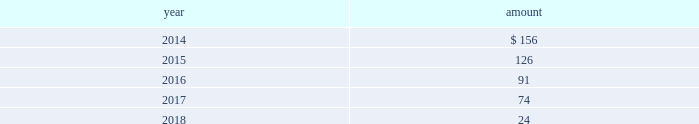The impairment tests performed for intangible assets as of july 31 , 2013 , 2012 and 2011 indicated no impairment charges were required .
Estimated amortization expense for finite-lived intangible assets for each of the five succeeding years is as follows : ( in millions ) .
Indefinite-lived acquired management contracts in july 2013 , in connection with the credit suisse etf transaction , the company acquired $ 231 million of indefinite-lived management contracts .
In march 2012 , in connection with the claymore transaction , the company acquired $ 163 million of indefinite-lived etp management contracts .
Finite-lived acquired management contracts in october 2013 , in connection with the mgpa transaction , the company acquired $ 29 million of finite-lived management contracts with a weighted-average estimated useful life of approximately eight years .
In september 2012 , in connection with the srpep transaction , the company acquired $ 40 million of finite- lived management contracts with a weighted-average estimated useful life of approximately 10 years .
11 .
Other assets at march 31 , 2013 , blackrock held an approximately one- third economic equity interest in private national mortgage acceptance company , llc ( 201cpnmac 201d ) , which is accounted for as an equity method investment and is included in other assets on the consolidated statements of financial condition .
On may 8 , 2013 , pennymac became the sole managing member of pnmac in connection with an initial public offering of pennymac ( the 201cpennymac ipo 201d ) .
As a result of the pennymac ipo , blackrock recorded a noncash , nonoperating pre-tax gain of $ 39 million related to the carrying value of its equity method investment .
Subsequent to the pennymac ipo , the company contributed 6.1 million units of its investment to a new donor advised fund ( the 201ccharitable contribution 201d ) .
The fair value of the charitable contribution was $ 124 million and is included in general and administration expenses on the consolidated statements of income .
In connection with the charitable contribution , the company also recorded a noncash , nonoperating pre-tax gain of $ 80 million related to the contributed investment and a tax benefit of approximately $ 48 million .
The carrying value and fair value of the company 2019s remaining interest ( approximately 20% ( 20 % ) or 16 million shares and units ) was approximately $ 127 million and $ 273 million , respectively , at december 31 , 2013 .
The fair value of the company 2019s interest reflected the pennymac stock price at december 31 , 2013 ( level 1 input ) .
12 .
Borrowings short-term borrowings the carrying value of short-term borrowings at december 31 , 2012 included $ 100 million under the 2012 revolving credit facility .
2013 revolving credit facility .
In march 2011 , the company entered into a five-year $ 3.5 billion unsecured revolving credit facility ( the 201c2011 credit facility 201d ) .
In march 2012 , the 2011 credit facility was amended to extend the maturity date by one year to march 2017 and in april 2012 the amount of the aggregate commitment was increased to $ 3.785 billion ( the 201c2012 credit facility 201d ) .
In march 2013 , the company 2019s credit facility was amended to extend the maturity date by one year to march 2018 and the amount of the aggregate commitment was increased to $ 3.990 billion ( the 201c2013 credit facility 201d ) .
The 2013 credit facility permits the company to request up to an additional $ 1.0 billion of borrowing capacity , subject to lender credit approval , increasing the overall size of the 2013 credit facility to an aggregate principal amount not to exceed $ 4.990 billion .
Interest on borrowings outstanding accrues at a rate based on the applicable london interbank offered rate plus a spread .
The 2013 credit facility requires the company not to exceed a maximum leverage ratio ( ratio of net debt to earnings before interest , taxes , depreciation and amortization , where net debt equals total debt less unrestricted cash ) of 3 to 1 , which was satisfied with a ratio of less than 1 to 1 at december 31 , 2013 .
The 2013 credit facility provides back- up liquidity , funds ongoing working capital for general corporate purposes and funds various investment opportunities .
At december 31 , 2013 , the company had no amount outstanding under the 2013 credit facility .
Commercial paper program .
On october 14 , 2009 , blackrock established a commercial paper program ( the 201ccp program 201d ) under which the company could issue unsecured commercial paper notes ( the 201ccp notes 201d ) on a private placement basis up to a maximum aggregate amount outstanding at any time of $ 3.0 billion .
On may 13 , 2011 , blackrock increased the maximum aggregate amount that may be borrowed under the cp program to $ 3.5 billion .
On may 17 , 2012 , blackrock increased the maximum aggregate amount to $ 3.785 billion .
In april 2013 , blackrock increased the maximum aggregate amount for which the company could issue unsecured cp notes on a private-placement basis up to a maximum aggregate amount outstanding at any time of $ 3.990 billion .
The commercial paper program is currently supported by the 2013 credit facility .
At december 31 , 2013 and 2012 , blackrock had no cp notes outstanding. .
What is the annual amortization expense related to srpep transaction of 2012 , in millions? 
Computations: (40 / 10)
Answer: 4.0. 